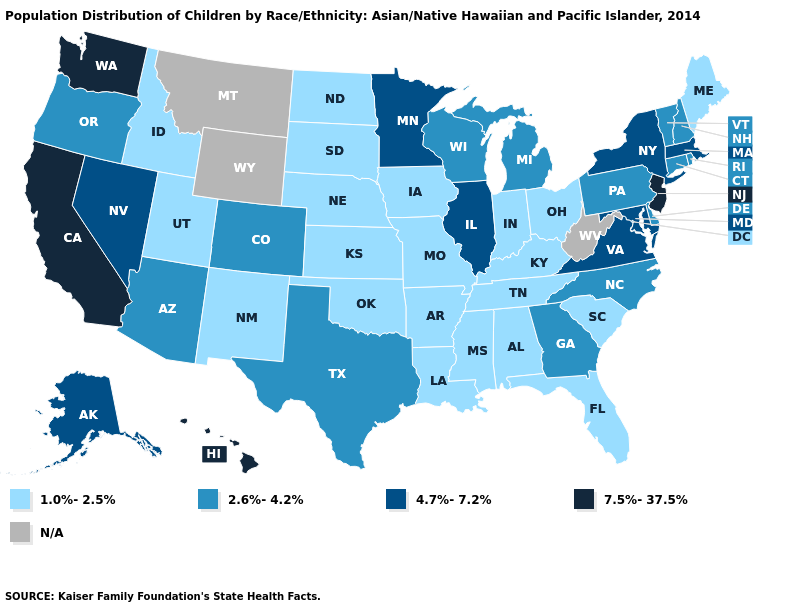Which states have the lowest value in the West?
Be succinct. Idaho, New Mexico, Utah. Name the states that have a value in the range 2.6%-4.2%?
Concise answer only. Arizona, Colorado, Connecticut, Delaware, Georgia, Michigan, New Hampshire, North Carolina, Oregon, Pennsylvania, Rhode Island, Texas, Vermont, Wisconsin. Is the legend a continuous bar?
Be succinct. No. Name the states that have a value in the range 4.7%-7.2%?
Quick response, please. Alaska, Illinois, Maryland, Massachusetts, Minnesota, Nevada, New York, Virginia. What is the value of Hawaii?
Answer briefly. 7.5%-37.5%. Does New Jersey have the highest value in the USA?
Answer briefly. Yes. What is the value of Michigan?
Give a very brief answer. 2.6%-4.2%. Does Michigan have the lowest value in the USA?
Be succinct. No. Name the states that have a value in the range 2.6%-4.2%?
Concise answer only. Arizona, Colorado, Connecticut, Delaware, Georgia, Michigan, New Hampshire, North Carolina, Oregon, Pennsylvania, Rhode Island, Texas, Vermont, Wisconsin. Which states have the lowest value in the MidWest?
Write a very short answer. Indiana, Iowa, Kansas, Missouri, Nebraska, North Dakota, Ohio, South Dakota. Name the states that have a value in the range 4.7%-7.2%?
Quick response, please. Alaska, Illinois, Maryland, Massachusetts, Minnesota, Nevada, New York, Virginia. Which states have the lowest value in the USA?
Concise answer only. Alabama, Arkansas, Florida, Idaho, Indiana, Iowa, Kansas, Kentucky, Louisiana, Maine, Mississippi, Missouri, Nebraska, New Mexico, North Dakota, Ohio, Oklahoma, South Carolina, South Dakota, Tennessee, Utah. What is the value of Massachusetts?
Quick response, please. 4.7%-7.2%. Is the legend a continuous bar?
Keep it brief. No. 